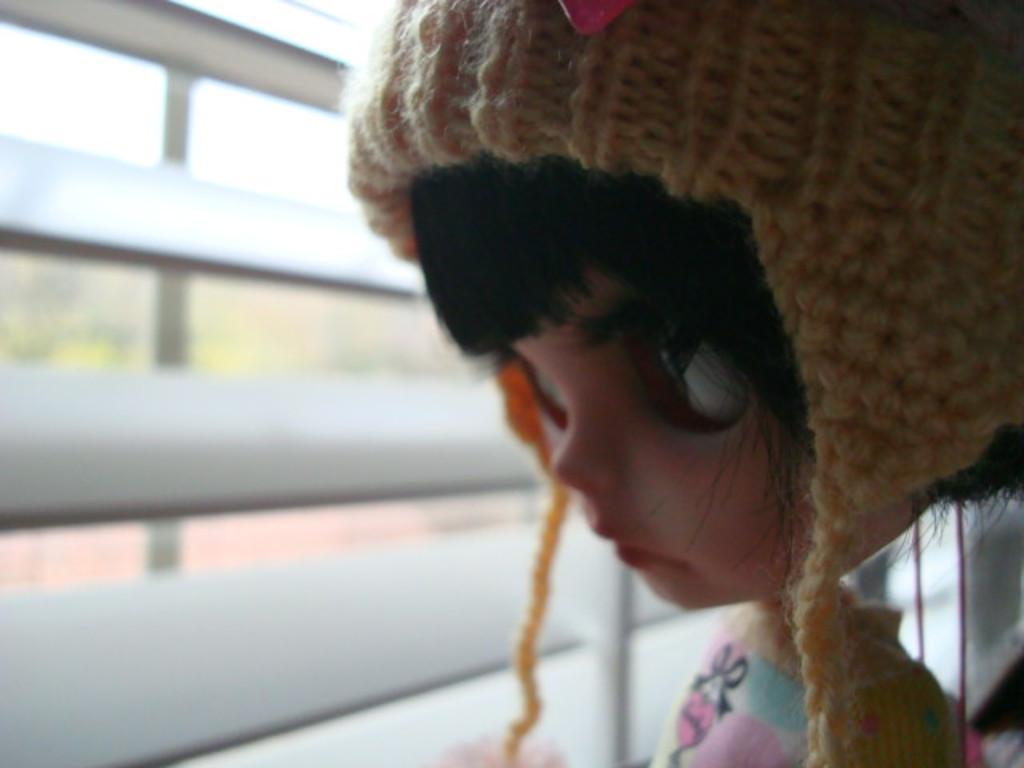Could you give a brief overview of what you see in this image? In this image, we can see a doll and we can see a window. 